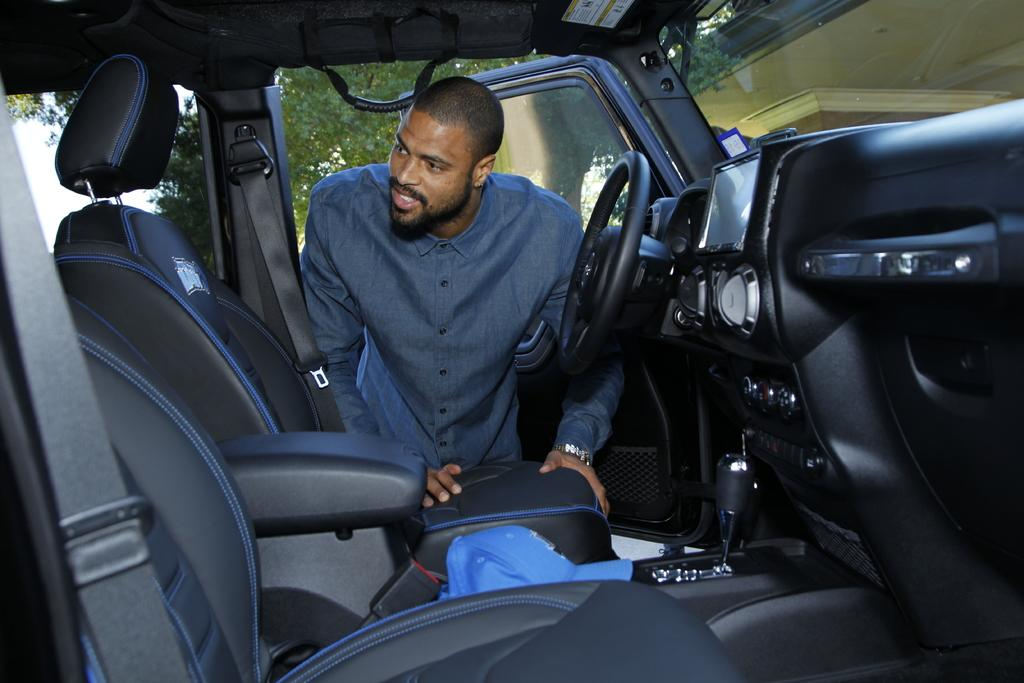What is the person in the image doing? The person is standing near a car. What can be seen on the right side of the image? There is a building on the right side of the image. What type of vegetation is visible in the image? There is a tree visible at the back of the image. What type of amusement can be seen in the image? There is no amusement present in the image; it features a person standing near a car, a building, and a tree. What type of bait is being used by the person in the image? There is no bait present in the image; the person is simply standing near a car. 